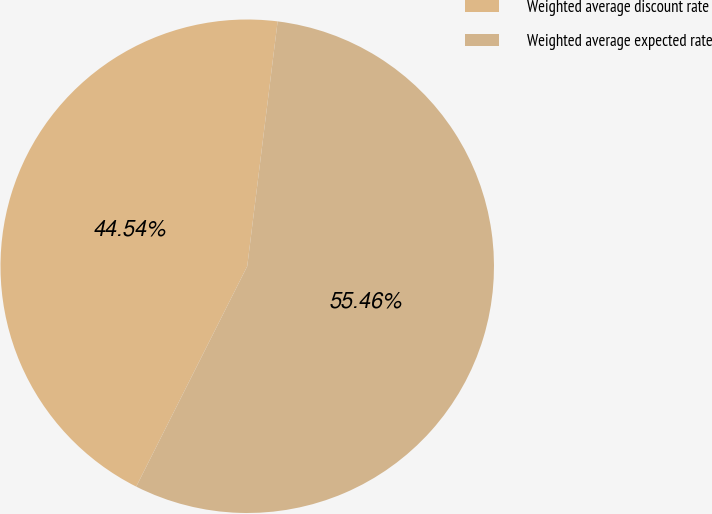Convert chart. <chart><loc_0><loc_0><loc_500><loc_500><pie_chart><fcel>Weighted average discount rate<fcel>Weighted average expected rate<nl><fcel>44.54%<fcel>55.46%<nl></chart> 